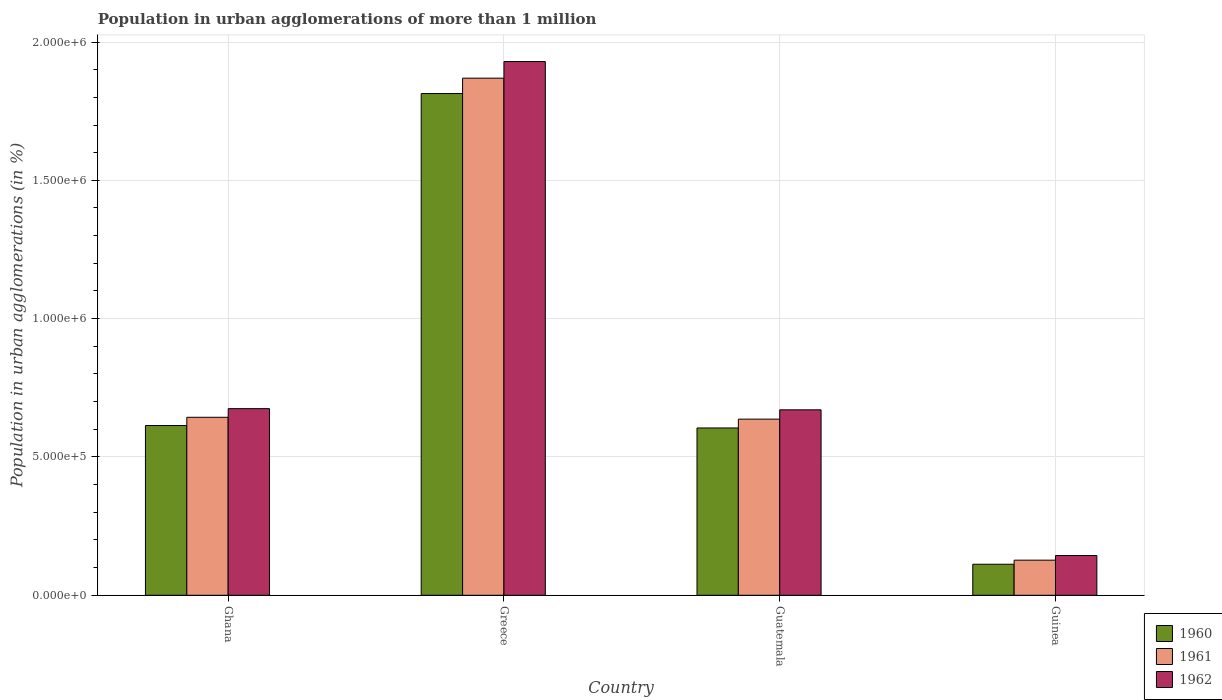How many groups of bars are there?
Make the answer very short. 4. Are the number of bars per tick equal to the number of legend labels?
Your answer should be compact. Yes. How many bars are there on the 4th tick from the left?
Keep it short and to the point. 3. How many bars are there on the 4th tick from the right?
Ensure brevity in your answer.  3. What is the label of the 1st group of bars from the left?
Make the answer very short. Ghana. What is the population in urban agglomerations in 1960 in Ghana?
Your answer should be very brief. 6.14e+05. Across all countries, what is the maximum population in urban agglomerations in 1961?
Make the answer very short. 1.87e+06. Across all countries, what is the minimum population in urban agglomerations in 1960?
Provide a short and direct response. 1.12e+05. In which country was the population in urban agglomerations in 1962 maximum?
Make the answer very short. Greece. In which country was the population in urban agglomerations in 1961 minimum?
Keep it short and to the point. Guinea. What is the total population in urban agglomerations in 1960 in the graph?
Make the answer very short. 3.14e+06. What is the difference between the population in urban agglomerations in 1962 in Ghana and that in Guatemala?
Make the answer very short. 4222. What is the difference between the population in urban agglomerations in 1960 in Ghana and the population in urban agglomerations in 1961 in Guinea?
Keep it short and to the point. 4.87e+05. What is the average population in urban agglomerations in 1962 per country?
Your answer should be very brief. 8.55e+05. What is the difference between the population in urban agglomerations of/in 1960 and population in urban agglomerations of/in 1962 in Greece?
Your answer should be very brief. -1.16e+05. What is the ratio of the population in urban agglomerations in 1961 in Ghana to that in Greece?
Offer a very short reply. 0.34. Is the difference between the population in urban agglomerations in 1960 in Ghana and Guinea greater than the difference between the population in urban agglomerations in 1962 in Ghana and Guinea?
Offer a very short reply. No. What is the difference between the highest and the second highest population in urban agglomerations in 1961?
Provide a succinct answer. -6641. What is the difference between the highest and the lowest population in urban agglomerations in 1961?
Your answer should be compact. 1.74e+06. In how many countries, is the population in urban agglomerations in 1960 greater than the average population in urban agglomerations in 1960 taken over all countries?
Offer a very short reply. 1. Is the sum of the population in urban agglomerations in 1962 in Guatemala and Guinea greater than the maximum population in urban agglomerations in 1961 across all countries?
Offer a terse response. No. Is it the case that in every country, the sum of the population in urban agglomerations in 1961 and population in urban agglomerations in 1960 is greater than the population in urban agglomerations in 1962?
Your answer should be compact. Yes. How many countries are there in the graph?
Keep it short and to the point. 4. Does the graph contain any zero values?
Ensure brevity in your answer.  No. Where does the legend appear in the graph?
Your answer should be compact. Bottom right. How many legend labels are there?
Your response must be concise. 3. How are the legend labels stacked?
Your answer should be very brief. Vertical. What is the title of the graph?
Ensure brevity in your answer.  Population in urban agglomerations of more than 1 million. Does "1971" appear as one of the legend labels in the graph?
Make the answer very short. No. What is the label or title of the X-axis?
Provide a short and direct response. Country. What is the label or title of the Y-axis?
Make the answer very short. Population in urban agglomerations (in %). What is the Population in urban agglomerations (in %) in 1960 in Ghana?
Provide a short and direct response. 6.14e+05. What is the Population in urban agglomerations (in %) of 1961 in Ghana?
Offer a terse response. 6.43e+05. What is the Population in urban agglomerations (in %) of 1962 in Ghana?
Offer a very short reply. 6.75e+05. What is the Population in urban agglomerations (in %) in 1960 in Greece?
Provide a short and direct response. 1.81e+06. What is the Population in urban agglomerations (in %) in 1961 in Greece?
Your response must be concise. 1.87e+06. What is the Population in urban agglomerations (in %) of 1962 in Greece?
Make the answer very short. 1.93e+06. What is the Population in urban agglomerations (in %) in 1960 in Guatemala?
Give a very brief answer. 6.05e+05. What is the Population in urban agglomerations (in %) in 1961 in Guatemala?
Ensure brevity in your answer.  6.37e+05. What is the Population in urban agglomerations (in %) of 1962 in Guatemala?
Offer a very short reply. 6.70e+05. What is the Population in urban agglomerations (in %) of 1960 in Guinea?
Provide a succinct answer. 1.12e+05. What is the Population in urban agglomerations (in %) in 1961 in Guinea?
Give a very brief answer. 1.27e+05. What is the Population in urban agglomerations (in %) in 1962 in Guinea?
Your answer should be compact. 1.44e+05. Across all countries, what is the maximum Population in urban agglomerations (in %) in 1960?
Give a very brief answer. 1.81e+06. Across all countries, what is the maximum Population in urban agglomerations (in %) of 1961?
Give a very brief answer. 1.87e+06. Across all countries, what is the maximum Population in urban agglomerations (in %) of 1962?
Keep it short and to the point. 1.93e+06. Across all countries, what is the minimum Population in urban agglomerations (in %) of 1960?
Provide a succinct answer. 1.12e+05. Across all countries, what is the minimum Population in urban agglomerations (in %) of 1961?
Your answer should be very brief. 1.27e+05. Across all countries, what is the minimum Population in urban agglomerations (in %) in 1962?
Your answer should be very brief. 1.44e+05. What is the total Population in urban agglomerations (in %) of 1960 in the graph?
Your answer should be compact. 3.14e+06. What is the total Population in urban agglomerations (in %) in 1961 in the graph?
Make the answer very short. 3.28e+06. What is the total Population in urban agglomerations (in %) of 1962 in the graph?
Provide a succinct answer. 3.42e+06. What is the difference between the Population in urban agglomerations (in %) in 1960 in Ghana and that in Greece?
Offer a terse response. -1.20e+06. What is the difference between the Population in urban agglomerations (in %) in 1961 in Ghana and that in Greece?
Offer a very short reply. -1.23e+06. What is the difference between the Population in urban agglomerations (in %) of 1962 in Ghana and that in Greece?
Your response must be concise. -1.25e+06. What is the difference between the Population in urban agglomerations (in %) of 1960 in Ghana and that in Guatemala?
Your answer should be compact. 8816. What is the difference between the Population in urban agglomerations (in %) of 1961 in Ghana and that in Guatemala?
Make the answer very short. 6641. What is the difference between the Population in urban agglomerations (in %) of 1962 in Ghana and that in Guatemala?
Your answer should be very brief. 4222. What is the difference between the Population in urban agglomerations (in %) of 1960 in Ghana and that in Guinea?
Make the answer very short. 5.01e+05. What is the difference between the Population in urban agglomerations (in %) of 1961 in Ghana and that in Guinea?
Your answer should be very brief. 5.16e+05. What is the difference between the Population in urban agglomerations (in %) in 1962 in Ghana and that in Guinea?
Give a very brief answer. 5.31e+05. What is the difference between the Population in urban agglomerations (in %) of 1960 in Greece and that in Guatemala?
Make the answer very short. 1.21e+06. What is the difference between the Population in urban agglomerations (in %) of 1961 in Greece and that in Guatemala?
Provide a succinct answer. 1.23e+06. What is the difference between the Population in urban agglomerations (in %) of 1962 in Greece and that in Guatemala?
Your answer should be compact. 1.26e+06. What is the difference between the Population in urban agglomerations (in %) in 1960 in Greece and that in Guinea?
Offer a terse response. 1.70e+06. What is the difference between the Population in urban agglomerations (in %) in 1961 in Greece and that in Guinea?
Your answer should be compact. 1.74e+06. What is the difference between the Population in urban agglomerations (in %) in 1962 in Greece and that in Guinea?
Your response must be concise. 1.79e+06. What is the difference between the Population in urban agglomerations (in %) in 1960 in Guatemala and that in Guinea?
Keep it short and to the point. 4.93e+05. What is the difference between the Population in urban agglomerations (in %) of 1961 in Guatemala and that in Guinea?
Provide a succinct answer. 5.10e+05. What is the difference between the Population in urban agglomerations (in %) of 1962 in Guatemala and that in Guinea?
Your response must be concise. 5.27e+05. What is the difference between the Population in urban agglomerations (in %) of 1960 in Ghana and the Population in urban agglomerations (in %) of 1961 in Greece?
Provide a succinct answer. -1.26e+06. What is the difference between the Population in urban agglomerations (in %) in 1960 in Ghana and the Population in urban agglomerations (in %) in 1962 in Greece?
Offer a very short reply. -1.32e+06. What is the difference between the Population in urban agglomerations (in %) in 1961 in Ghana and the Population in urban agglomerations (in %) in 1962 in Greece?
Provide a succinct answer. -1.29e+06. What is the difference between the Population in urban agglomerations (in %) of 1960 in Ghana and the Population in urban agglomerations (in %) of 1961 in Guatemala?
Give a very brief answer. -2.31e+04. What is the difference between the Population in urban agglomerations (in %) of 1960 in Ghana and the Population in urban agglomerations (in %) of 1962 in Guatemala?
Offer a very short reply. -5.68e+04. What is the difference between the Population in urban agglomerations (in %) in 1961 in Ghana and the Population in urban agglomerations (in %) in 1962 in Guatemala?
Ensure brevity in your answer.  -2.70e+04. What is the difference between the Population in urban agglomerations (in %) of 1960 in Ghana and the Population in urban agglomerations (in %) of 1961 in Guinea?
Give a very brief answer. 4.87e+05. What is the difference between the Population in urban agglomerations (in %) in 1960 in Ghana and the Population in urban agglomerations (in %) in 1962 in Guinea?
Keep it short and to the point. 4.70e+05. What is the difference between the Population in urban agglomerations (in %) of 1961 in Ghana and the Population in urban agglomerations (in %) of 1962 in Guinea?
Ensure brevity in your answer.  5.00e+05. What is the difference between the Population in urban agglomerations (in %) in 1960 in Greece and the Population in urban agglomerations (in %) in 1961 in Guatemala?
Provide a succinct answer. 1.18e+06. What is the difference between the Population in urban agglomerations (in %) of 1960 in Greece and the Population in urban agglomerations (in %) of 1962 in Guatemala?
Offer a terse response. 1.14e+06. What is the difference between the Population in urban agglomerations (in %) in 1961 in Greece and the Population in urban agglomerations (in %) in 1962 in Guatemala?
Offer a terse response. 1.20e+06. What is the difference between the Population in urban agglomerations (in %) in 1960 in Greece and the Population in urban agglomerations (in %) in 1961 in Guinea?
Make the answer very short. 1.69e+06. What is the difference between the Population in urban agglomerations (in %) in 1960 in Greece and the Population in urban agglomerations (in %) in 1962 in Guinea?
Your response must be concise. 1.67e+06. What is the difference between the Population in urban agglomerations (in %) of 1961 in Greece and the Population in urban agglomerations (in %) of 1962 in Guinea?
Keep it short and to the point. 1.73e+06. What is the difference between the Population in urban agglomerations (in %) in 1960 in Guatemala and the Population in urban agglomerations (in %) in 1961 in Guinea?
Offer a very short reply. 4.78e+05. What is the difference between the Population in urban agglomerations (in %) in 1960 in Guatemala and the Population in urban agglomerations (in %) in 1962 in Guinea?
Make the answer very short. 4.61e+05. What is the difference between the Population in urban agglomerations (in %) of 1961 in Guatemala and the Population in urban agglomerations (in %) of 1962 in Guinea?
Offer a very short reply. 4.93e+05. What is the average Population in urban agglomerations (in %) of 1960 per country?
Offer a terse response. 7.86e+05. What is the average Population in urban agglomerations (in %) in 1961 per country?
Keep it short and to the point. 8.19e+05. What is the average Population in urban agglomerations (in %) of 1962 per country?
Offer a very short reply. 8.55e+05. What is the difference between the Population in urban agglomerations (in %) in 1960 and Population in urban agglomerations (in %) in 1961 in Ghana?
Ensure brevity in your answer.  -2.98e+04. What is the difference between the Population in urban agglomerations (in %) of 1960 and Population in urban agglomerations (in %) of 1962 in Ghana?
Give a very brief answer. -6.10e+04. What is the difference between the Population in urban agglomerations (in %) of 1961 and Population in urban agglomerations (in %) of 1962 in Ghana?
Provide a succinct answer. -3.12e+04. What is the difference between the Population in urban agglomerations (in %) in 1960 and Population in urban agglomerations (in %) in 1961 in Greece?
Your response must be concise. -5.56e+04. What is the difference between the Population in urban agglomerations (in %) in 1960 and Population in urban agglomerations (in %) in 1962 in Greece?
Provide a short and direct response. -1.16e+05. What is the difference between the Population in urban agglomerations (in %) in 1961 and Population in urban agglomerations (in %) in 1962 in Greece?
Provide a short and direct response. -6.00e+04. What is the difference between the Population in urban agglomerations (in %) in 1960 and Population in urban agglomerations (in %) in 1961 in Guatemala?
Offer a terse response. -3.19e+04. What is the difference between the Population in urban agglomerations (in %) in 1960 and Population in urban agglomerations (in %) in 1962 in Guatemala?
Keep it short and to the point. -6.56e+04. What is the difference between the Population in urban agglomerations (in %) in 1961 and Population in urban agglomerations (in %) in 1962 in Guatemala?
Your answer should be compact. -3.37e+04. What is the difference between the Population in urban agglomerations (in %) in 1960 and Population in urban agglomerations (in %) in 1961 in Guinea?
Your answer should be very brief. -1.48e+04. What is the difference between the Population in urban agglomerations (in %) in 1960 and Population in urban agglomerations (in %) in 1962 in Guinea?
Your answer should be very brief. -3.15e+04. What is the difference between the Population in urban agglomerations (in %) in 1961 and Population in urban agglomerations (in %) in 1962 in Guinea?
Your answer should be very brief. -1.68e+04. What is the ratio of the Population in urban agglomerations (in %) in 1960 in Ghana to that in Greece?
Provide a short and direct response. 0.34. What is the ratio of the Population in urban agglomerations (in %) in 1961 in Ghana to that in Greece?
Provide a succinct answer. 0.34. What is the ratio of the Population in urban agglomerations (in %) in 1962 in Ghana to that in Greece?
Your answer should be very brief. 0.35. What is the ratio of the Population in urban agglomerations (in %) of 1960 in Ghana to that in Guatemala?
Keep it short and to the point. 1.01. What is the ratio of the Population in urban agglomerations (in %) in 1961 in Ghana to that in Guatemala?
Make the answer very short. 1.01. What is the ratio of the Population in urban agglomerations (in %) in 1962 in Ghana to that in Guatemala?
Make the answer very short. 1.01. What is the ratio of the Population in urban agglomerations (in %) of 1960 in Ghana to that in Guinea?
Give a very brief answer. 5.47. What is the ratio of the Population in urban agglomerations (in %) in 1961 in Ghana to that in Guinea?
Provide a succinct answer. 5.07. What is the ratio of the Population in urban agglomerations (in %) in 1962 in Ghana to that in Guinea?
Your answer should be compact. 4.69. What is the ratio of the Population in urban agglomerations (in %) in 1960 in Greece to that in Guatemala?
Your response must be concise. 3. What is the ratio of the Population in urban agglomerations (in %) in 1961 in Greece to that in Guatemala?
Provide a succinct answer. 2.94. What is the ratio of the Population in urban agglomerations (in %) in 1962 in Greece to that in Guatemala?
Make the answer very short. 2.88. What is the ratio of the Population in urban agglomerations (in %) of 1960 in Greece to that in Guinea?
Your answer should be very brief. 16.17. What is the ratio of the Population in urban agglomerations (in %) in 1961 in Greece to that in Guinea?
Your answer should be compact. 14.73. What is the ratio of the Population in urban agglomerations (in %) in 1962 in Greece to that in Guinea?
Give a very brief answer. 13.43. What is the ratio of the Population in urban agglomerations (in %) of 1960 in Guatemala to that in Guinea?
Offer a terse response. 5.39. What is the ratio of the Population in urban agglomerations (in %) of 1961 in Guatemala to that in Guinea?
Provide a succinct answer. 5.02. What is the ratio of the Population in urban agglomerations (in %) in 1962 in Guatemala to that in Guinea?
Make the answer very short. 4.67. What is the difference between the highest and the second highest Population in urban agglomerations (in %) in 1960?
Provide a succinct answer. 1.20e+06. What is the difference between the highest and the second highest Population in urban agglomerations (in %) in 1961?
Provide a short and direct response. 1.23e+06. What is the difference between the highest and the second highest Population in urban agglomerations (in %) in 1962?
Your answer should be very brief. 1.25e+06. What is the difference between the highest and the lowest Population in urban agglomerations (in %) of 1960?
Your answer should be compact. 1.70e+06. What is the difference between the highest and the lowest Population in urban agglomerations (in %) in 1961?
Give a very brief answer. 1.74e+06. What is the difference between the highest and the lowest Population in urban agglomerations (in %) of 1962?
Your response must be concise. 1.79e+06. 